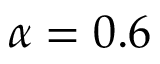<formula> <loc_0><loc_0><loc_500><loc_500>\alpha = 0 . 6</formula> 